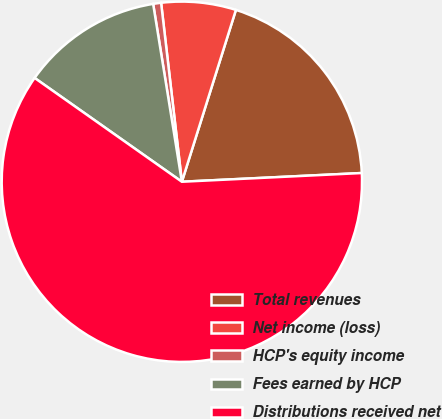<chart> <loc_0><loc_0><loc_500><loc_500><pie_chart><fcel>Total revenues<fcel>Net income (loss)<fcel>HCP's equity income<fcel>Fees earned by HCP<fcel>Distributions received net<nl><fcel>19.38%<fcel>6.69%<fcel>0.71%<fcel>12.68%<fcel>60.55%<nl></chart> 